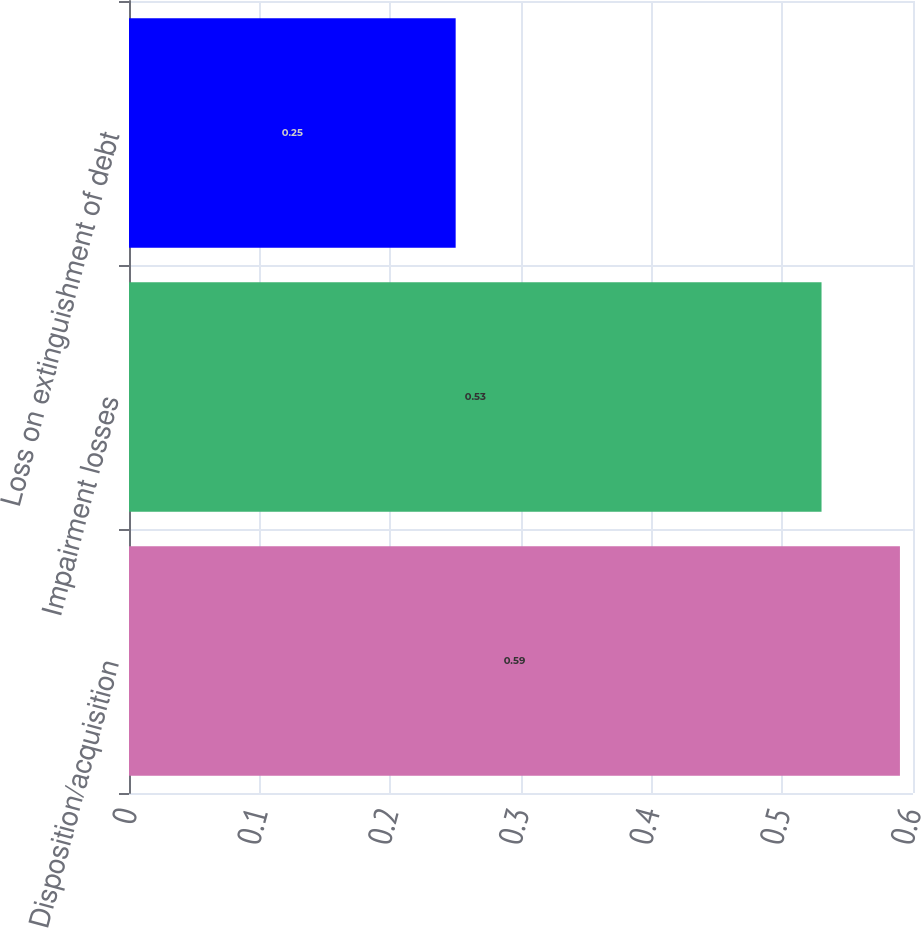<chart> <loc_0><loc_0><loc_500><loc_500><bar_chart><fcel>Disposition/acquisition<fcel>Impairment losses<fcel>Loss on extinguishment of debt<nl><fcel>0.59<fcel>0.53<fcel>0.25<nl></chart> 